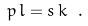<formula> <loc_0><loc_0><loc_500><loc_500>p \, l = s \, k \ .</formula> 